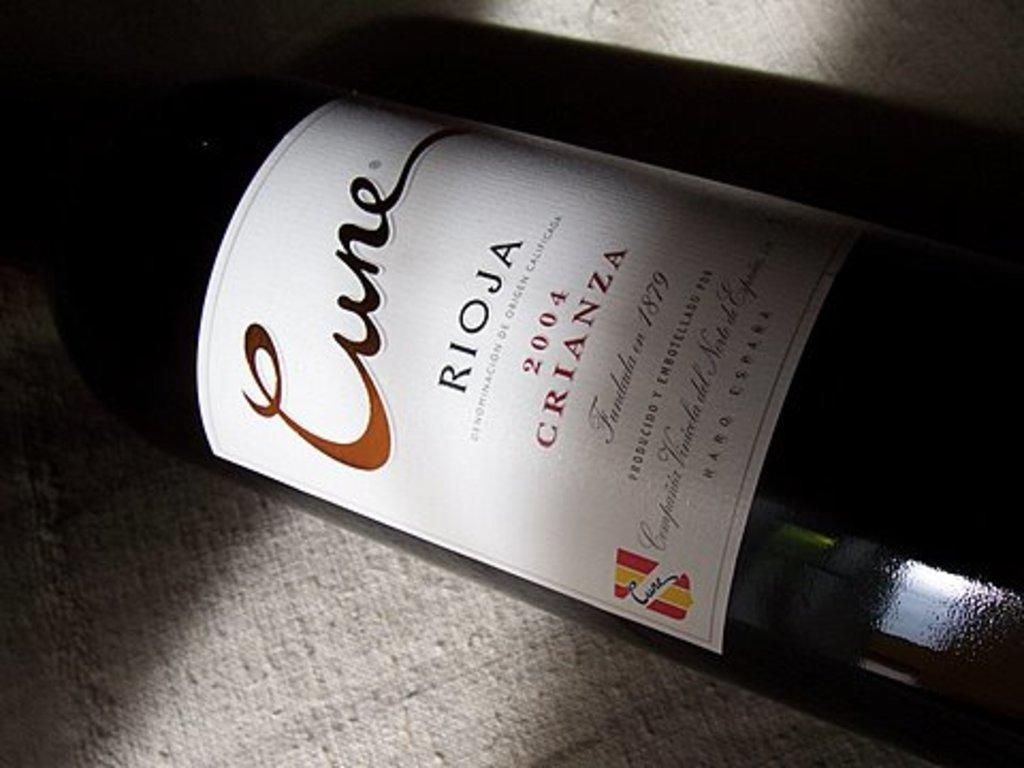<image>
Present a compact description of the photo's key features. A bottle of 2004 Crianza wine lies on a tan cloth. 